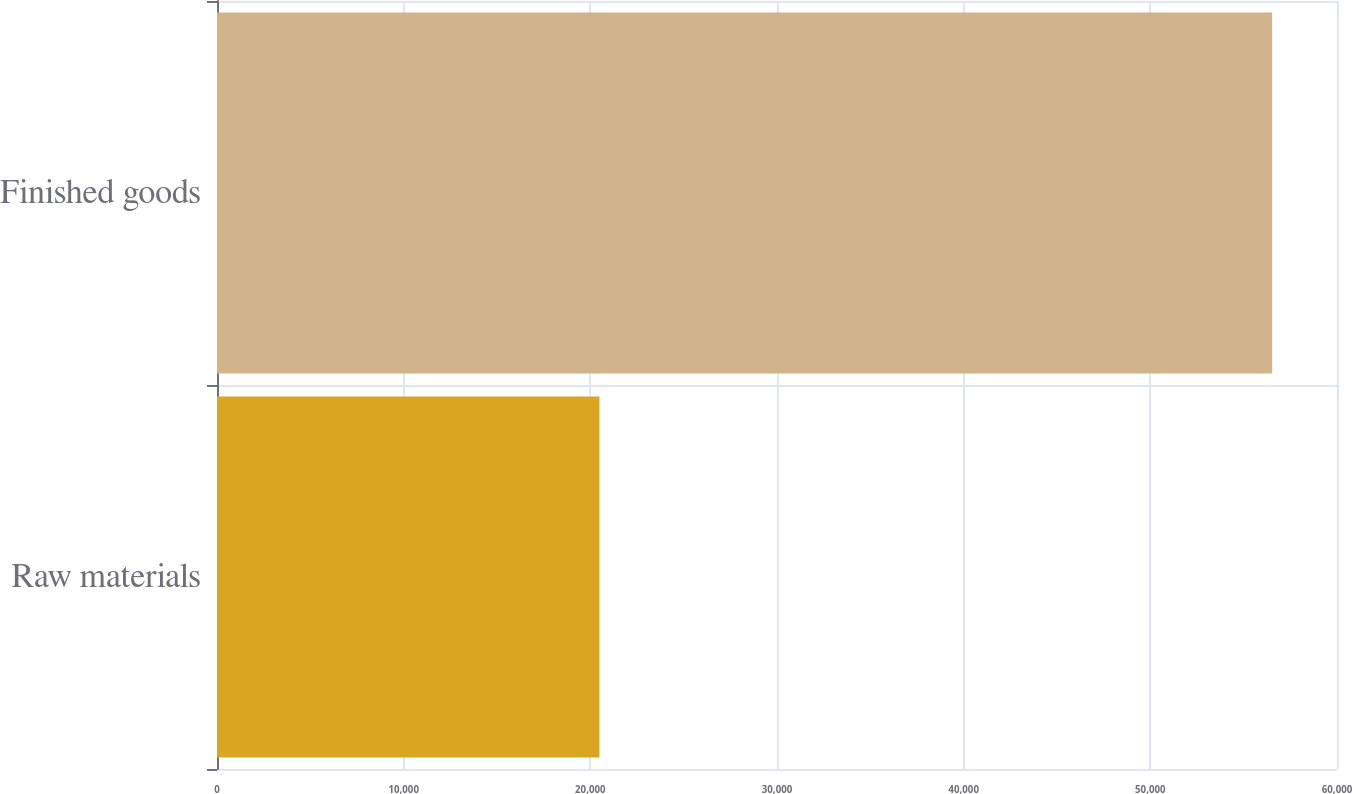Convert chart. <chart><loc_0><loc_0><loc_500><loc_500><bar_chart><fcel>Raw materials<fcel>Finished goods<nl><fcel>20488<fcel>56525<nl></chart> 